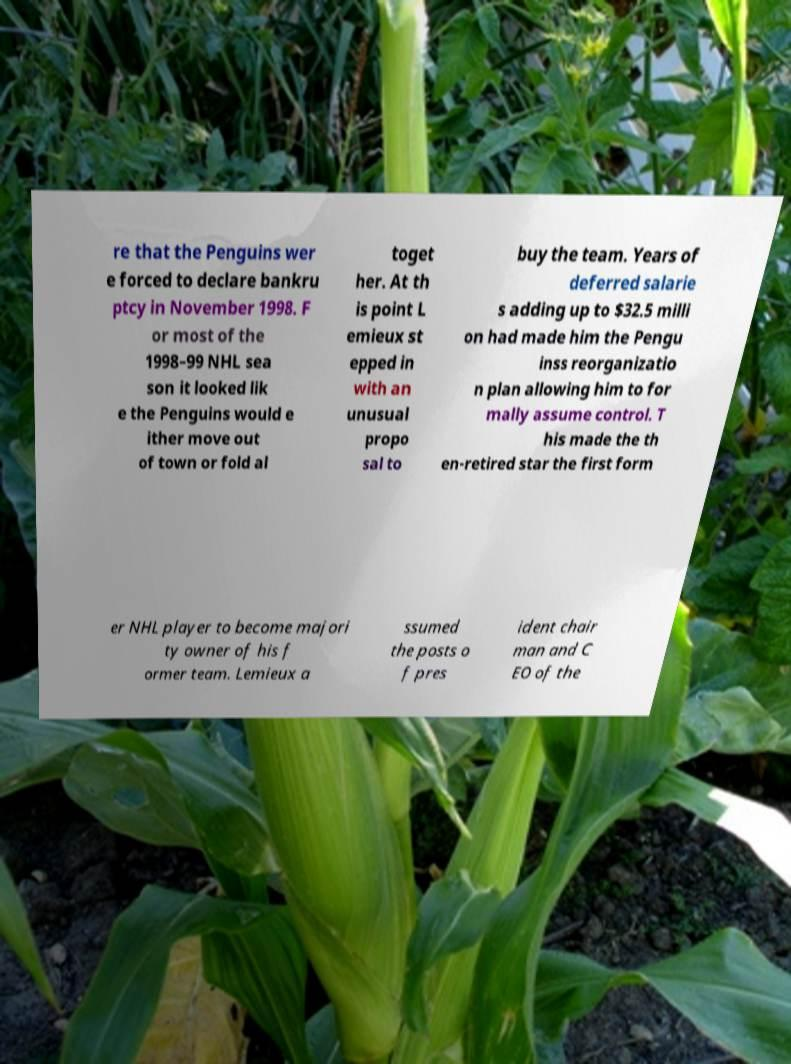Please read and relay the text visible in this image. What does it say? re that the Penguins wer e forced to declare bankru ptcy in November 1998. F or most of the 1998–99 NHL sea son it looked lik e the Penguins would e ither move out of town or fold al toget her. At th is point L emieux st epped in with an unusual propo sal to buy the team. Years of deferred salarie s adding up to $32.5 milli on had made him the Pengu inss reorganizatio n plan allowing him to for mally assume control. T his made the th en-retired star the first form er NHL player to become majori ty owner of his f ormer team. Lemieux a ssumed the posts o f pres ident chair man and C EO of the 